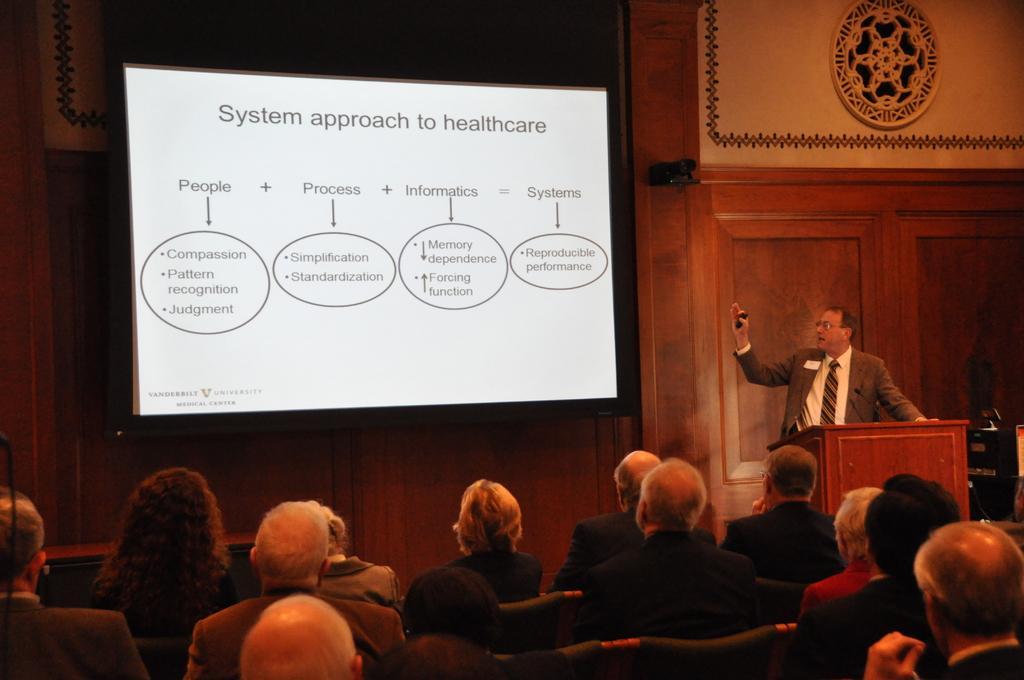How would you summarize this image in a sentence or two? At the bottom of the image there are people sitting on chairs. In the background of the image there is a wall with a screen. To the right side of the image there is a person standing. There is a podium. 